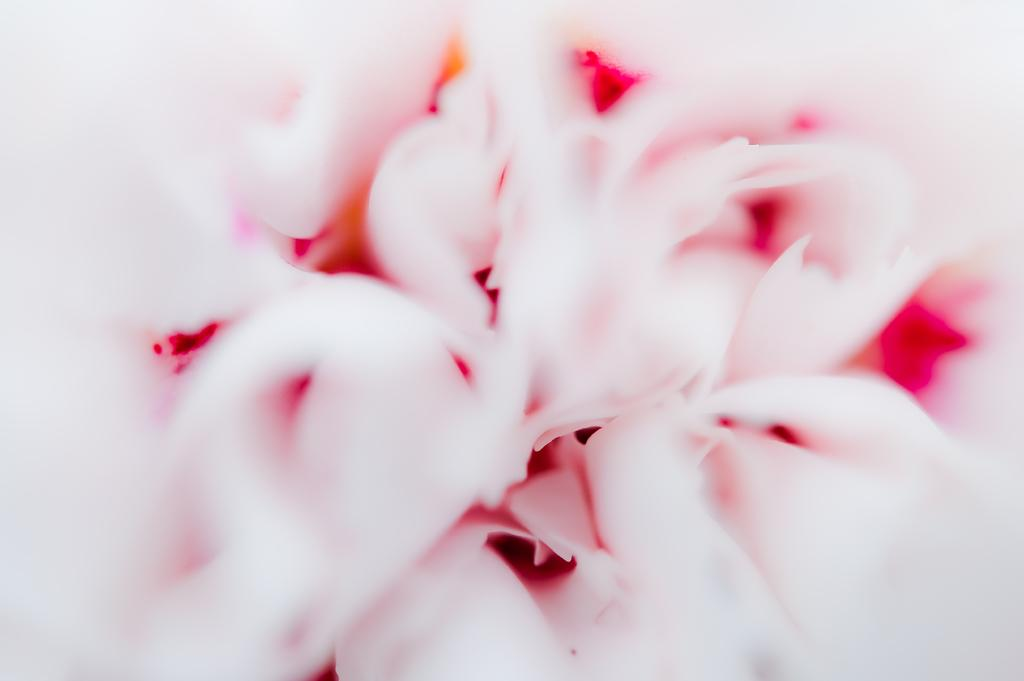What is the main subject in the image? There is an object in the image. What colors are present on the object? The object has light pink color and dark pink color. Is the object in the image a heart affected by a disease? There is no indication in the image that the object is a heart or affected by a disease. Can you tell me if the object is a balloon? There is no information in the image to determine if the object is a balloon or not. 